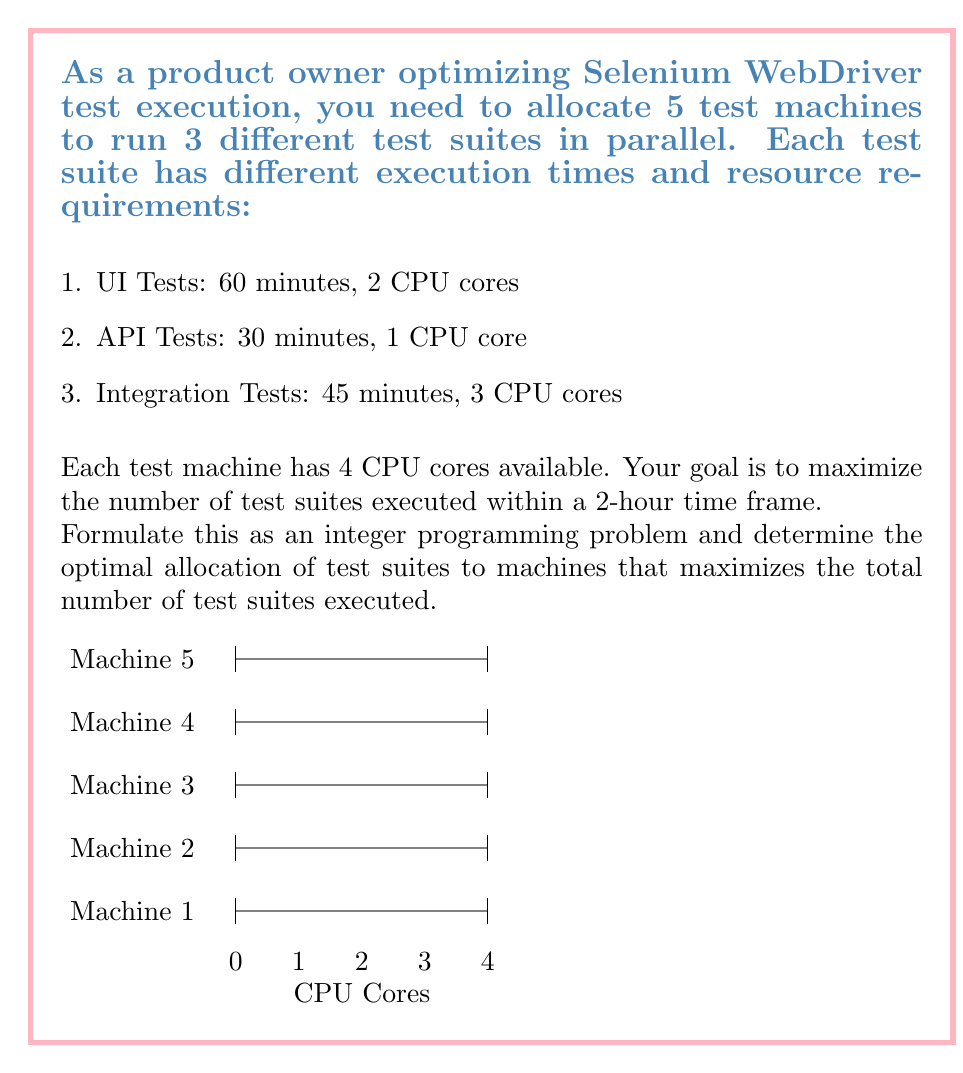Can you answer this question? Let's approach this step-by-step:

1) Define variables:
   Let $x_i$, $y_i$, and $z_i$ be the number of UI, API, and Integration tests run on machine $i$ respectively, where $i = 1, 2, 3, 4, 5$.

2) Objective function:
   Maximize the total number of test suites:
   $$\text{Max } Z = \sum_{i=1}^5 (x_i + y_i + z_i)$$

3) Constraints:
   a) CPU core constraints for each machine:
      $$2x_i + y_i + 3z_i \leq 4 \text{ for } i = 1, 2, 3, 4, 5$$

   b) Time constraints (120 minutes available):
      $$60x_i + 30y_i + 45z_i \leq 120 \text{ for } i = 1, 2, 3, 4, 5$$

   c) Non-negativity and integer constraints:
      $$x_i, y_i, z_i \geq 0 \text{ and integer for } i = 1, 2, 3, 4, 5$$

4) Solving this integer programming problem (using an IP solver) gives the optimal solution:
   - For each machine: Run 1 UI test and 2 API tests
   - This solution is the same for all 5 machines due to symmetry

5) Verification:
   - CPU cores used per machine: 2(1) + 1(2) = 4 cores (satisfies constraint)
   - Time used per machine: 60(1) + 30(2) = 120 minutes (satisfies constraint)
   - Total test suites executed: 5(1 + 2) = 15

Therefore, the optimal allocation is to run 1 UI test and 2 API tests on each of the 5 machines, resulting in a total of 15 test suites executed within the 2-hour time frame.
Answer: 15 test suites (5 UI, 10 API) 